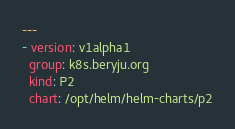<code> <loc_0><loc_0><loc_500><loc_500><_YAML_>---
- version: v1alpha1
  group: k8s.beryju.org
  kind: P2
  chart: /opt/helm/helm-charts/p2
</code> 